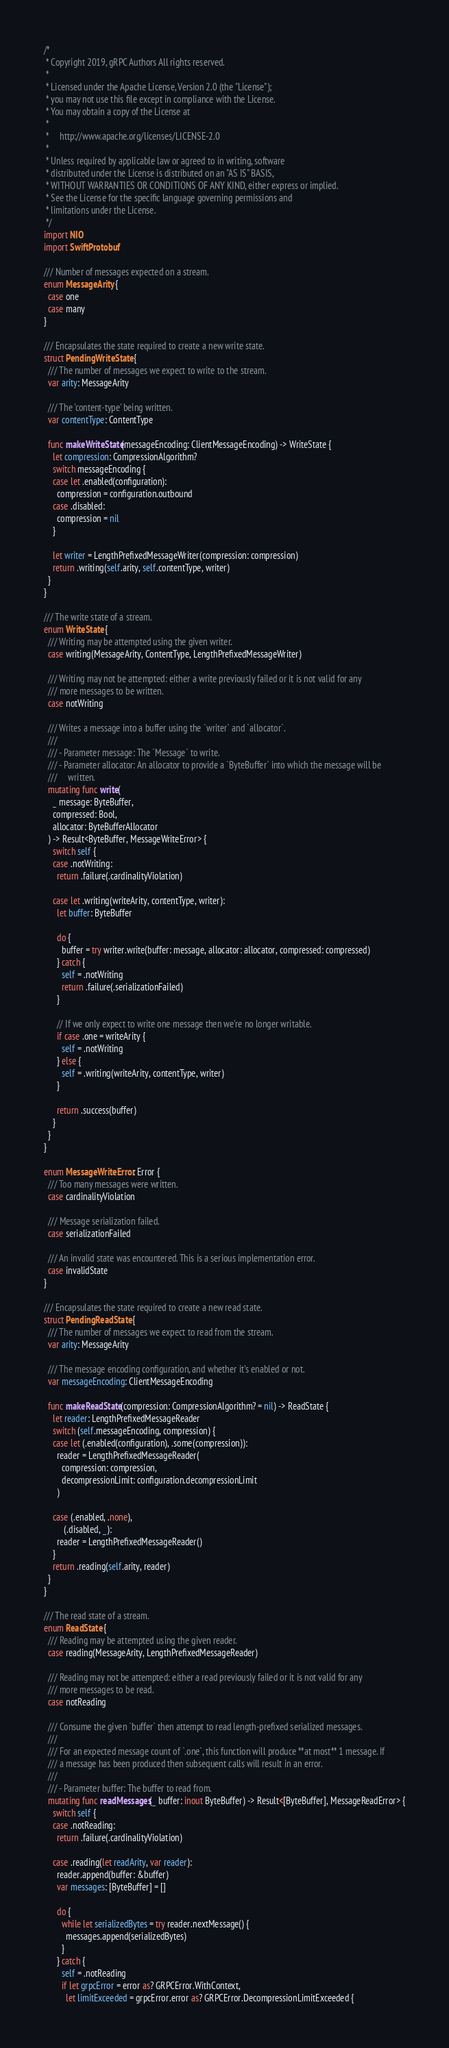Convert code to text. <code><loc_0><loc_0><loc_500><loc_500><_Swift_>/*
 * Copyright 2019, gRPC Authors All rights reserved.
 *
 * Licensed under the Apache License, Version 2.0 (the "License");
 * you may not use this file except in compliance with the License.
 * You may obtain a copy of the License at
 *
 *     http://www.apache.org/licenses/LICENSE-2.0
 *
 * Unless required by applicable law or agreed to in writing, software
 * distributed under the License is distributed on an "AS IS" BASIS,
 * WITHOUT WARRANTIES OR CONDITIONS OF ANY KIND, either express or implied.
 * See the License for the specific language governing permissions and
 * limitations under the License.
 */
import NIO
import SwiftProtobuf

/// Number of messages expected on a stream.
enum MessageArity {
  case one
  case many
}

/// Encapsulates the state required to create a new write state.
struct PendingWriteState {
  /// The number of messages we expect to write to the stream.
  var arity: MessageArity

  /// The 'content-type' being written.
  var contentType: ContentType

  func makeWriteState(messageEncoding: ClientMessageEncoding) -> WriteState {
    let compression: CompressionAlgorithm?
    switch messageEncoding {
    case let .enabled(configuration):
      compression = configuration.outbound
    case .disabled:
      compression = nil
    }

    let writer = LengthPrefixedMessageWriter(compression: compression)
    return .writing(self.arity, self.contentType, writer)
  }
}

/// The write state of a stream.
enum WriteState {
  /// Writing may be attempted using the given writer.
  case writing(MessageArity, ContentType, LengthPrefixedMessageWriter)

  /// Writing may not be attempted: either a write previously failed or it is not valid for any
  /// more messages to be written.
  case notWriting

  /// Writes a message into a buffer using the `writer` and `allocator`.
  ///
  /// - Parameter message: The `Message` to write.
  /// - Parameter allocator: An allocator to provide a `ByteBuffer` into which the message will be
  ///     written.
  mutating func write(
    _ message: ByteBuffer,
    compressed: Bool,
    allocator: ByteBufferAllocator
  ) -> Result<ByteBuffer, MessageWriteError> {
    switch self {
    case .notWriting:
      return .failure(.cardinalityViolation)

    case let .writing(writeArity, contentType, writer):
      let buffer: ByteBuffer

      do {
        buffer = try writer.write(buffer: message, allocator: allocator, compressed: compressed)
      } catch {
        self = .notWriting
        return .failure(.serializationFailed)
      }

      // If we only expect to write one message then we're no longer writable.
      if case .one = writeArity {
        self = .notWriting
      } else {
        self = .writing(writeArity, contentType, writer)
      }

      return .success(buffer)
    }
  }
}

enum MessageWriteError: Error {
  /// Too many messages were written.
  case cardinalityViolation

  /// Message serialization failed.
  case serializationFailed

  /// An invalid state was encountered. This is a serious implementation error.
  case invalidState
}

/// Encapsulates the state required to create a new read state.
struct PendingReadState {
  /// The number of messages we expect to read from the stream.
  var arity: MessageArity

  /// The message encoding configuration, and whether it's enabled or not.
  var messageEncoding: ClientMessageEncoding

  func makeReadState(compression: CompressionAlgorithm? = nil) -> ReadState {
    let reader: LengthPrefixedMessageReader
    switch (self.messageEncoding, compression) {
    case let (.enabled(configuration), .some(compression)):
      reader = LengthPrefixedMessageReader(
        compression: compression,
        decompressionLimit: configuration.decompressionLimit
      )

    case (.enabled, .none),
         (.disabled, _):
      reader = LengthPrefixedMessageReader()
    }
    return .reading(self.arity, reader)
  }
}

/// The read state of a stream.
enum ReadState {
  /// Reading may be attempted using the given reader.
  case reading(MessageArity, LengthPrefixedMessageReader)

  /// Reading may not be attempted: either a read previously failed or it is not valid for any
  /// more messages to be read.
  case notReading

  /// Consume the given `buffer` then attempt to read length-prefixed serialized messages.
  ///
  /// For an expected message count of `.one`, this function will produce **at most** 1 message. If
  /// a message has been produced then subsequent calls will result in an error.
  ///
  /// - Parameter buffer: The buffer to read from.
  mutating func readMessages(_ buffer: inout ByteBuffer) -> Result<[ByteBuffer], MessageReadError> {
    switch self {
    case .notReading:
      return .failure(.cardinalityViolation)

    case .reading(let readArity, var reader):
      reader.append(buffer: &buffer)
      var messages: [ByteBuffer] = []

      do {
        while let serializedBytes = try reader.nextMessage() {
          messages.append(serializedBytes)
        }
      } catch {
        self = .notReading
        if let grpcError = error as? GRPCError.WithContext,
          let limitExceeded = grpcError.error as? GRPCError.DecompressionLimitExceeded {</code> 